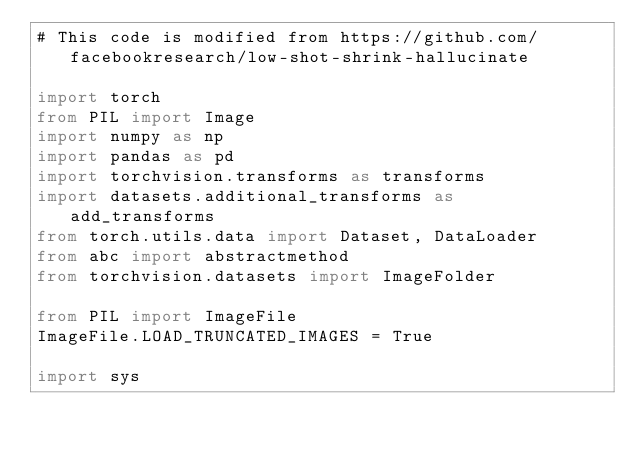<code> <loc_0><loc_0><loc_500><loc_500><_Python_># This code is modified from https://github.com/facebookresearch/low-shot-shrink-hallucinate

import torch
from PIL import Image
import numpy as np
import pandas as pd
import torchvision.transforms as transforms
import datasets.additional_transforms as add_transforms
from torch.utils.data import Dataset, DataLoader
from abc import abstractmethod
from torchvision.datasets import ImageFolder

from PIL import ImageFile
ImageFile.LOAD_TRUNCATED_IMAGES = True

import sys</code> 